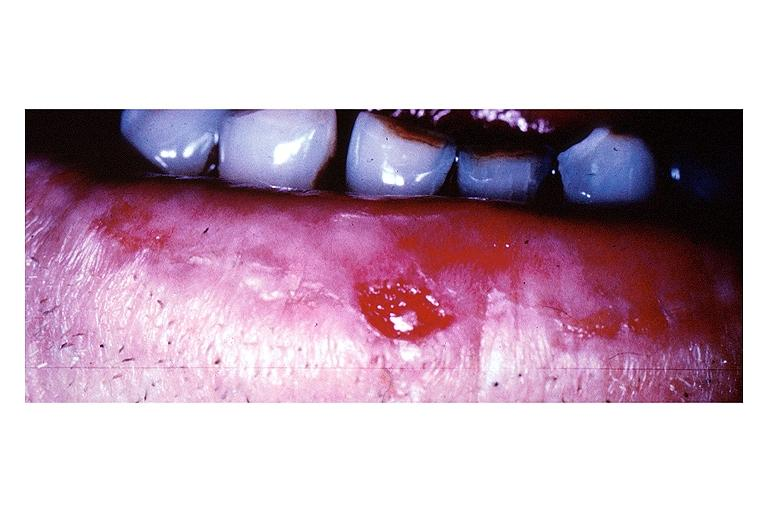s very good example present?
Answer the question using a single word or phrase. No 